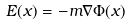<formula> <loc_0><loc_0><loc_500><loc_500>E ( x ) = - m \nabla \Phi ( x )</formula> 